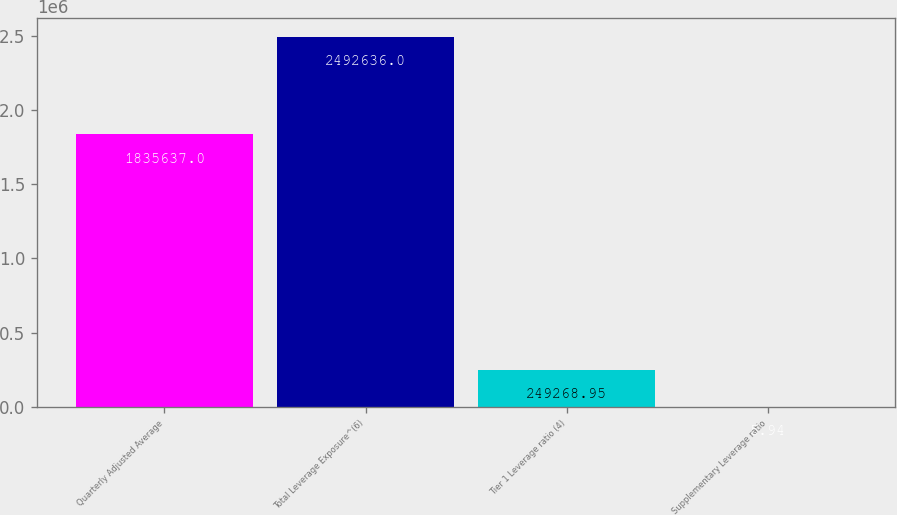Convert chart to OTSL. <chart><loc_0><loc_0><loc_500><loc_500><bar_chart><fcel>Quarterly Adjusted Average<fcel>Total Leverage Exposure^(6)<fcel>Tier 1 Leverage ratio (4)<fcel>Supplementary Leverage ratio<nl><fcel>1.83564e+06<fcel>2.49264e+06<fcel>249269<fcel>5.94<nl></chart> 